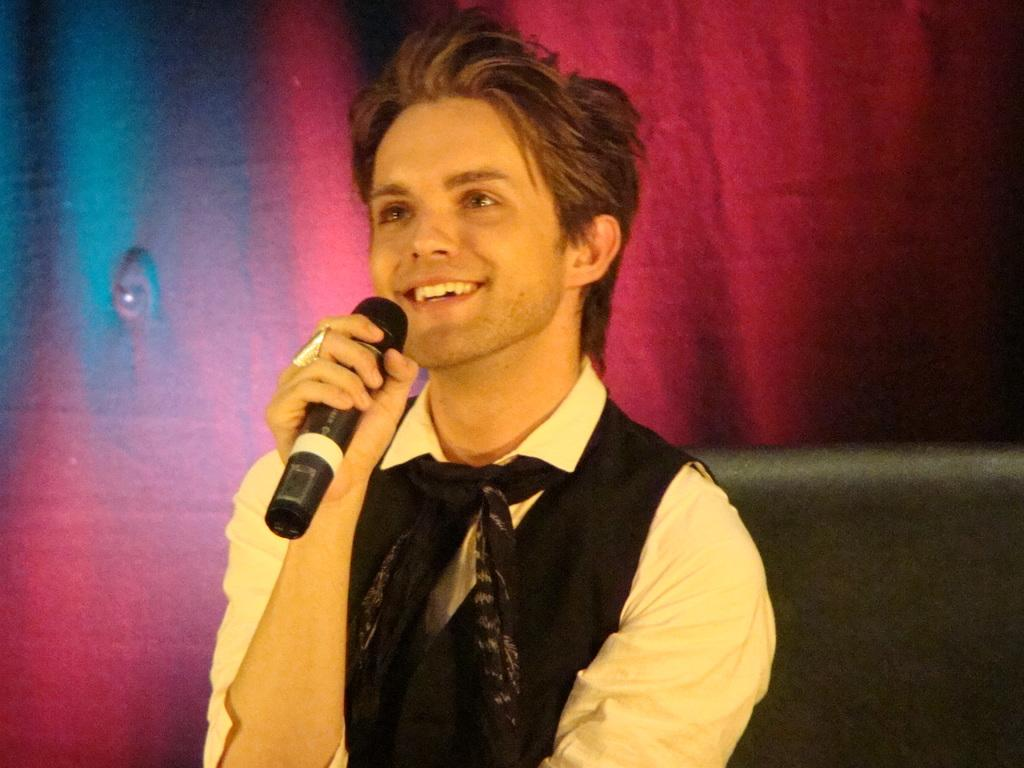Who is the main subject in the image? There is a man in the image. What is the man wearing? The man is wearing a black coat. What is the man doing in the image? The man is talking through a mic. What expression does the man have? The man is smiling. What type of furniture is present in the image? There is a black color sofa in the image. What can be seen in the background of the image? There is a red curtain in the background. What type of government policy is being discussed by the man in the image? There is no indication in the image that the man is discussing any government policy. How does the man slip on the drain in the image? There is no drain present in the image, and the man is not slipping. 